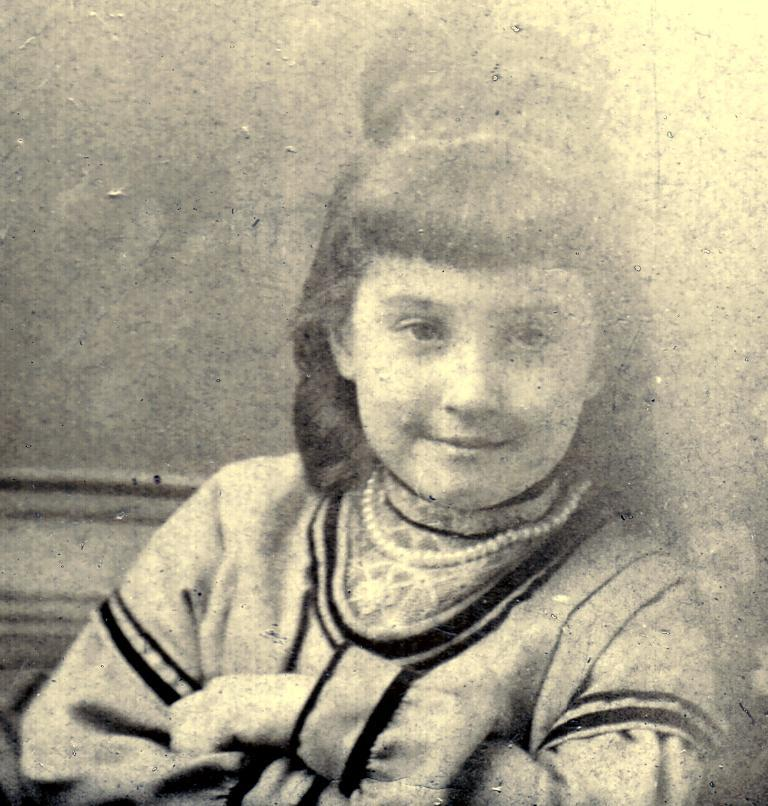Who is the main subject in the image? There is a girl in the image. Where is the girl located in relation to the image? The girl is in the foreground. What is the girl wearing in the image? The girl is wearing a pearl necklace. What is the size of the duck in the image? There is no duck present in the image. What type of authority does the girl have in the image? The image does not provide any information about the girl's authority. 